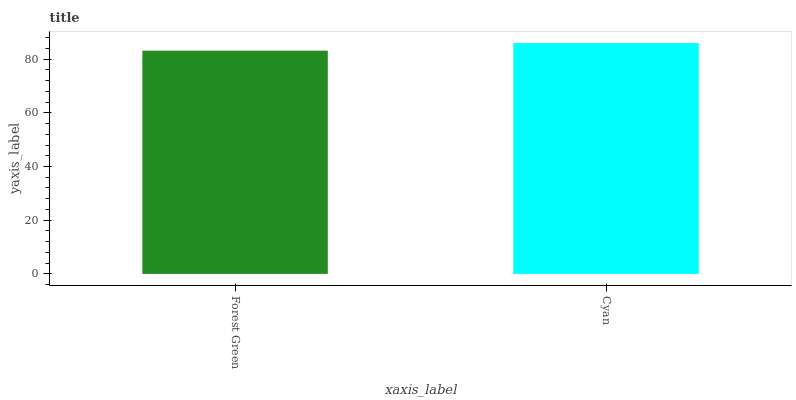Is Cyan the minimum?
Answer yes or no. No. Is Cyan greater than Forest Green?
Answer yes or no. Yes. Is Forest Green less than Cyan?
Answer yes or no. Yes. Is Forest Green greater than Cyan?
Answer yes or no. No. Is Cyan less than Forest Green?
Answer yes or no. No. Is Cyan the high median?
Answer yes or no. Yes. Is Forest Green the low median?
Answer yes or no. Yes. Is Forest Green the high median?
Answer yes or no. No. Is Cyan the low median?
Answer yes or no. No. 